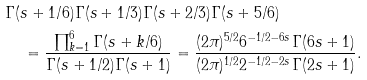Convert formula to latex. <formula><loc_0><loc_0><loc_500><loc_500>& \Gamma ( s + 1 / 6 ) \Gamma ( s + 1 / 3 ) \Gamma ( s + 2 / 3 ) \Gamma ( s + 5 / 6 ) \\ & \quad = \frac { \prod _ { k = 1 } ^ { 6 } \Gamma ( s + k / 6 ) } { \Gamma ( s + 1 / 2 ) \Gamma ( s + 1 ) } = \frac { ( 2 \pi ) ^ { 5 / 2 } 6 ^ { - 1 / 2 - 6 s } \Gamma ( 6 s + 1 ) } { ( 2 \pi ) ^ { 1 / 2 } 2 ^ { - 1 / 2 - 2 s } \Gamma ( 2 s + 1 ) } .</formula> 